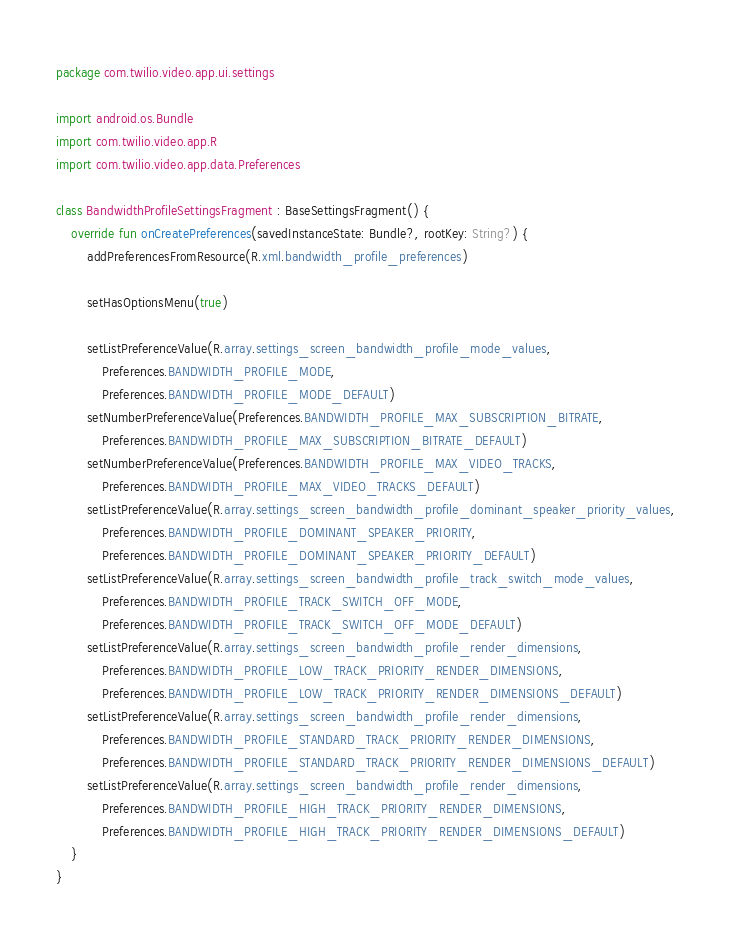Convert code to text. <code><loc_0><loc_0><loc_500><loc_500><_Kotlin_>package com.twilio.video.app.ui.settings

import android.os.Bundle
import com.twilio.video.app.R
import com.twilio.video.app.data.Preferences

class BandwidthProfileSettingsFragment : BaseSettingsFragment() {
    override fun onCreatePreferences(savedInstanceState: Bundle?, rootKey: String?) {
        addPreferencesFromResource(R.xml.bandwidth_profile_preferences)

        setHasOptionsMenu(true)

        setListPreferenceValue(R.array.settings_screen_bandwidth_profile_mode_values,
            Preferences.BANDWIDTH_PROFILE_MODE,
            Preferences.BANDWIDTH_PROFILE_MODE_DEFAULT)
        setNumberPreferenceValue(Preferences.BANDWIDTH_PROFILE_MAX_SUBSCRIPTION_BITRATE,
            Preferences.BANDWIDTH_PROFILE_MAX_SUBSCRIPTION_BITRATE_DEFAULT)
        setNumberPreferenceValue(Preferences.BANDWIDTH_PROFILE_MAX_VIDEO_TRACKS,
            Preferences.BANDWIDTH_PROFILE_MAX_VIDEO_TRACKS_DEFAULT)
        setListPreferenceValue(R.array.settings_screen_bandwidth_profile_dominant_speaker_priority_values,
            Preferences.BANDWIDTH_PROFILE_DOMINANT_SPEAKER_PRIORITY,
            Preferences.BANDWIDTH_PROFILE_DOMINANT_SPEAKER_PRIORITY_DEFAULT)
        setListPreferenceValue(R.array.settings_screen_bandwidth_profile_track_switch_mode_values,
            Preferences.BANDWIDTH_PROFILE_TRACK_SWITCH_OFF_MODE,
            Preferences.BANDWIDTH_PROFILE_TRACK_SWITCH_OFF_MODE_DEFAULT)
        setListPreferenceValue(R.array.settings_screen_bandwidth_profile_render_dimensions,
            Preferences.BANDWIDTH_PROFILE_LOW_TRACK_PRIORITY_RENDER_DIMENSIONS,
            Preferences.BANDWIDTH_PROFILE_LOW_TRACK_PRIORITY_RENDER_DIMENSIONS_DEFAULT)
        setListPreferenceValue(R.array.settings_screen_bandwidth_profile_render_dimensions,
            Preferences.BANDWIDTH_PROFILE_STANDARD_TRACK_PRIORITY_RENDER_DIMENSIONS,
            Preferences.BANDWIDTH_PROFILE_STANDARD_TRACK_PRIORITY_RENDER_DIMENSIONS_DEFAULT)
        setListPreferenceValue(R.array.settings_screen_bandwidth_profile_render_dimensions,
            Preferences.BANDWIDTH_PROFILE_HIGH_TRACK_PRIORITY_RENDER_DIMENSIONS,
            Preferences.BANDWIDTH_PROFILE_HIGH_TRACK_PRIORITY_RENDER_DIMENSIONS_DEFAULT)
    }
}
</code> 